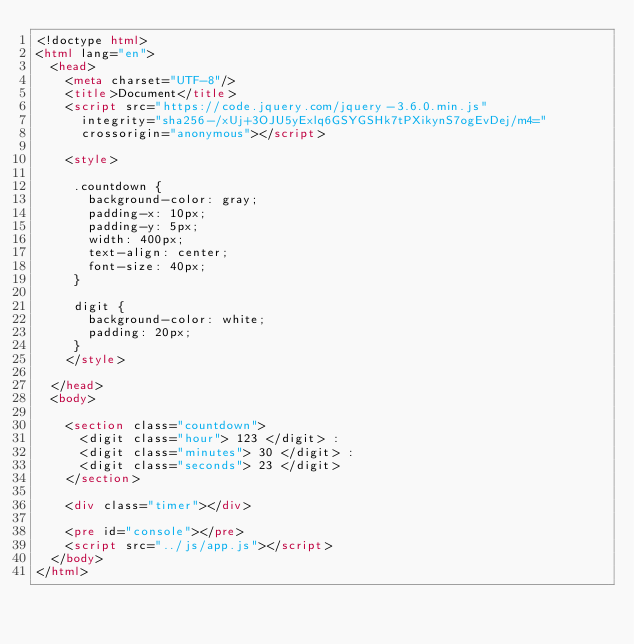<code> <loc_0><loc_0><loc_500><loc_500><_HTML_><!doctype html>
<html lang="en">
  <head>
    <meta charset="UTF-8"/>
    <title>Document</title>
    <script src="https://code.jquery.com/jquery-3.6.0.min.js"
	    integrity="sha256-/xUj+3OJU5yExlq6GSYGSHk7tPXikynS7ogEvDej/m4="
	    crossorigin="anonymous"></script>    

    <style>

     .countdown {
       background-color: gray;
       padding-x: 10px;
       padding-y: 5px;
       width: 400px;
       text-align: center;
       font-size: 40px;
     }

     digit {
       background-color: white;
       padding: 20px;
     }
    </style>

  </head>
  <body>

    <section class="countdown">
      <digit class="hour"> 123 </digit> : 
      <digit class="minutes"> 30 </digit> : 
      <digit class="seconds"> 23 </digit> 
    </section>

    <div class="timer"></div>

    <pre id="console"></pre>
    <script src="../js/app.js"></script>
  </body>
</html>
</code> 